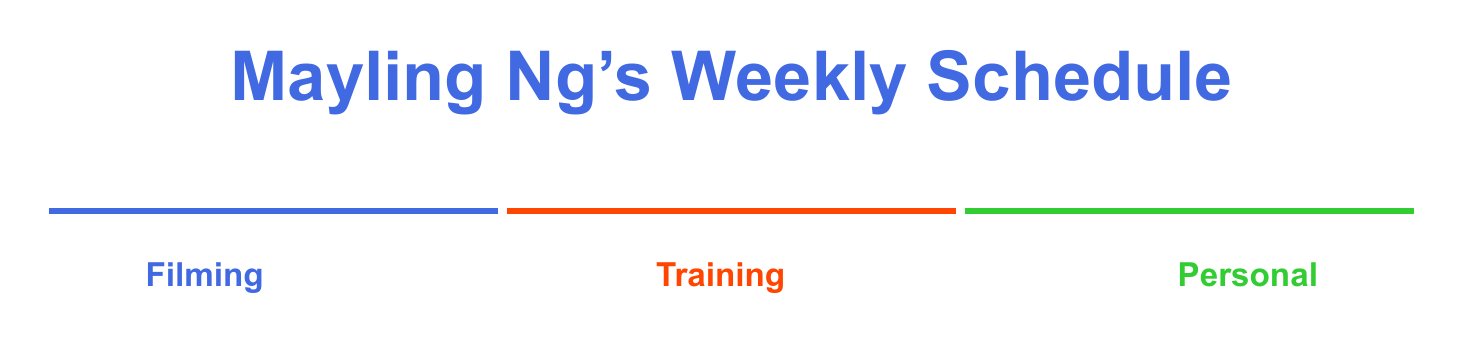what is the activity scheduled for Monday at 9:30? The activity is for filming for 'The Expendables 4' at Millennium Films Studio.
Answer: Filming for 'The Expendables 4' at Millennium Films Studio how long is the personal training session on Saturday? The personal training session is scheduled from 08:00 to 10:00, which is 2 hours.
Answer: 2 hours who is the personal trainer for the light training session on Sunday? The personal trainer is mentioned as just "personal trainer," no specific name is given.
Answer: personal trainer what is the color code for training activities? The color code for training activities is represented by the hex color #FF4500.
Answer: #FF4500 which activity starts first on Thursday? The activity scheduled first on Thursday is the boxing session with Freddie Roach at Wild Card Boxing Club.
Answer: Boxing session with Freddie Roach at Wild Card Boxing Club how many personal activities are there on Tuesday? There are 1 personal activities scheduled on Tuesday, which is the yoga session with Adriene Mishler.
Answer: 1 what category does the script reading on Wednesday fall under? The script reading is categorized under filming activities in the document.
Answer: Filming how many hours is the filming scheduled for on Friday? The filming duration on Friday is from 09:30 to 13:30, which is 4 hours.
Answer: 4 hours 